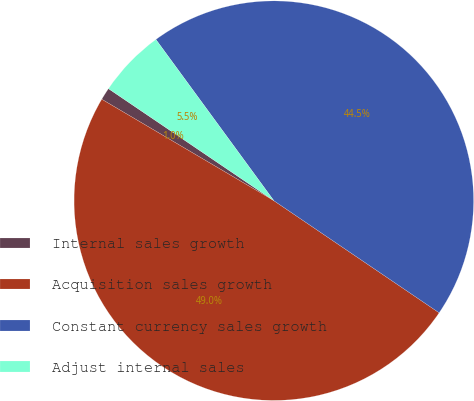Convert chart to OTSL. <chart><loc_0><loc_0><loc_500><loc_500><pie_chart><fcel>Internal sales growth<fcel>Acquisition sales growth<fcel>Constant currency sales growth<fcel>Adjust internal sales<nl><fcel>1.0%<fcel>48.99%<fcel>44.54%<fcel>5.47%<nl></chart> 